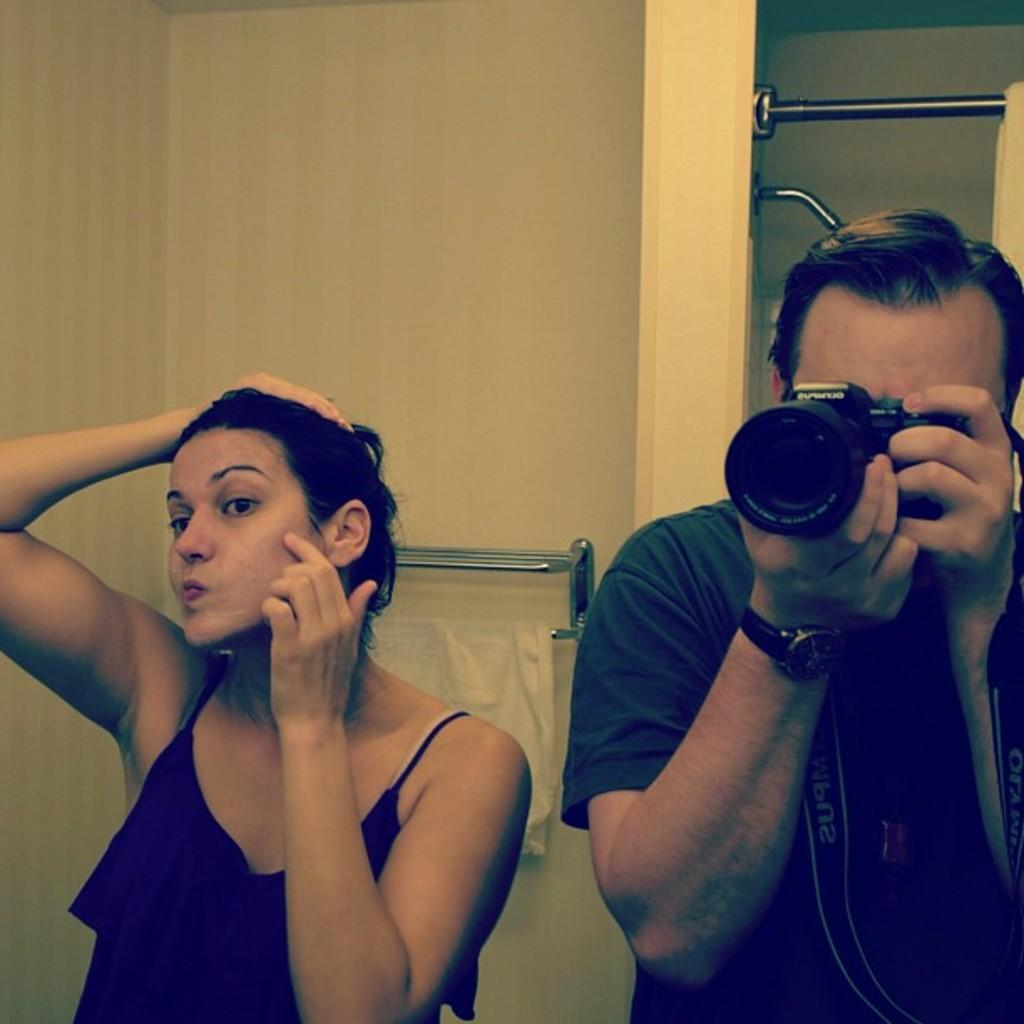What color is the wall in the image? There is a yellow color wall in the image. How many people are in the image? There are two people in the image. Can you describe one of the people in the image? One of the people is a man. What is the man doing in the image? The man is standing. What is the man holding in the image? The man is holding a camera. Is there a letter addressed to the man's grandmother on the wall in the image? There is no letter or mention of a grandmother in the image; it only features a yellow wall and two people. 